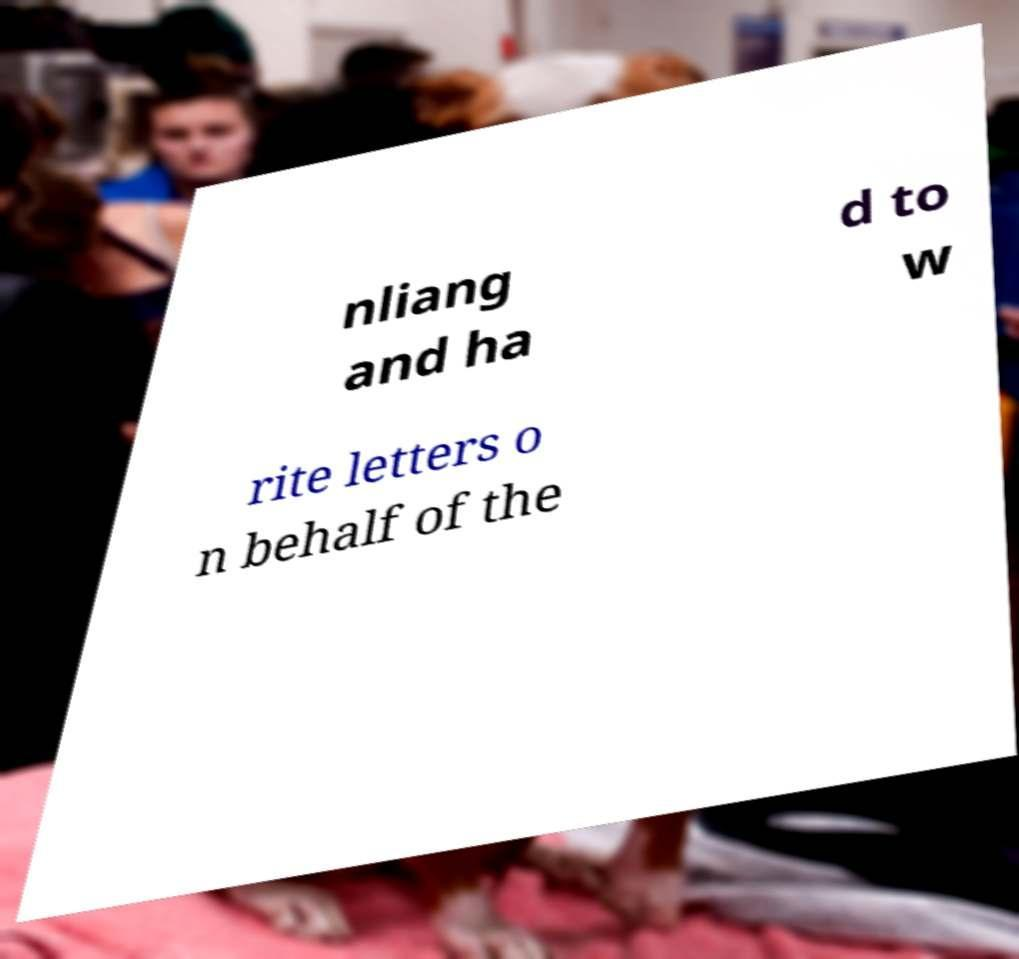I need the written content from this picture converted into text. Can you do that? nliang and ha d to w rite letters o n behalf of the 